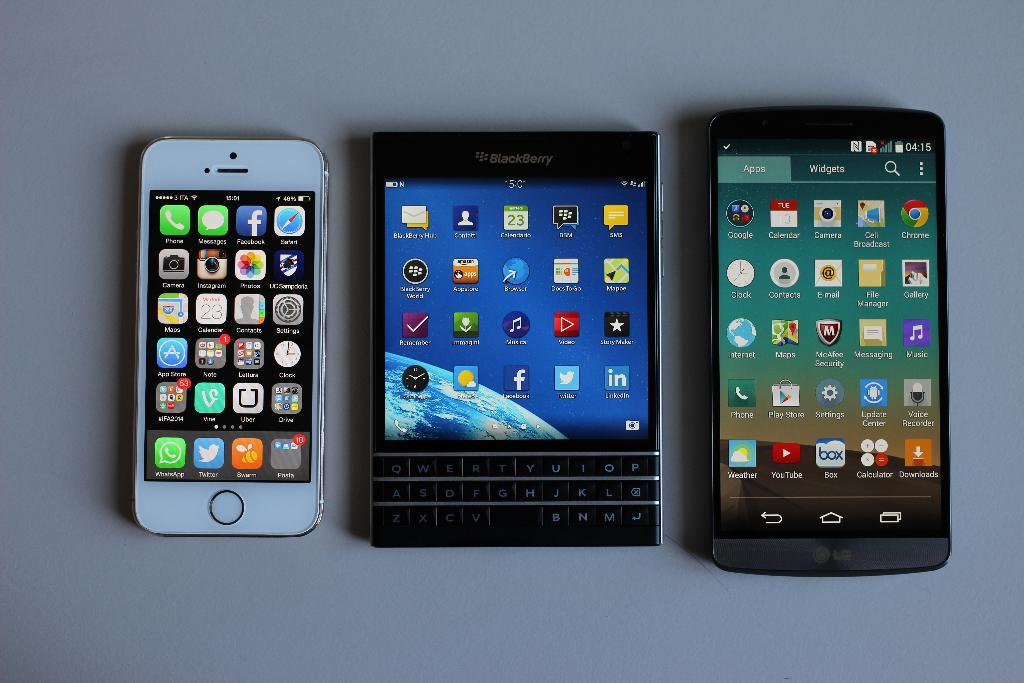Provide a one-sentence caption for the provided image. A trio of three phones are laid down on a surface, one is a LG and other a BLACKBERRY. 